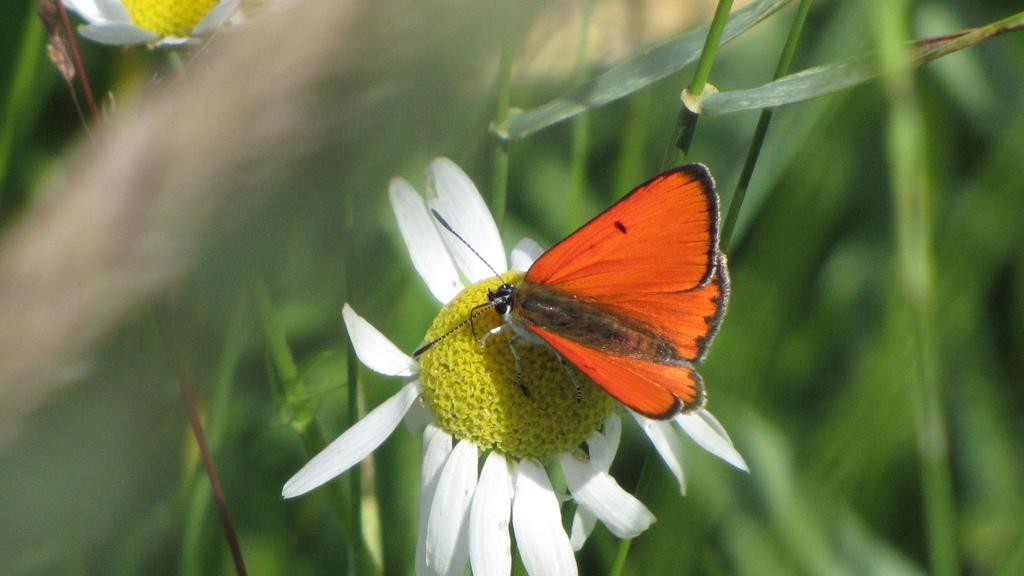What type of living organisms can be seen in the image? There are flowers in the image. What are the flowers situated on? The flowers are on plants. What colors are the flowers? The flowers are in yellow and white colors. Are there any other creatures present in the image? Yes, there is a butterfly on one of the flowers. What type of battle is taking place in the image? There is no battle present in the image; it features flowers, plants, and a butterfly. How many cars can be seen in the image? There are no cars present in the image. 